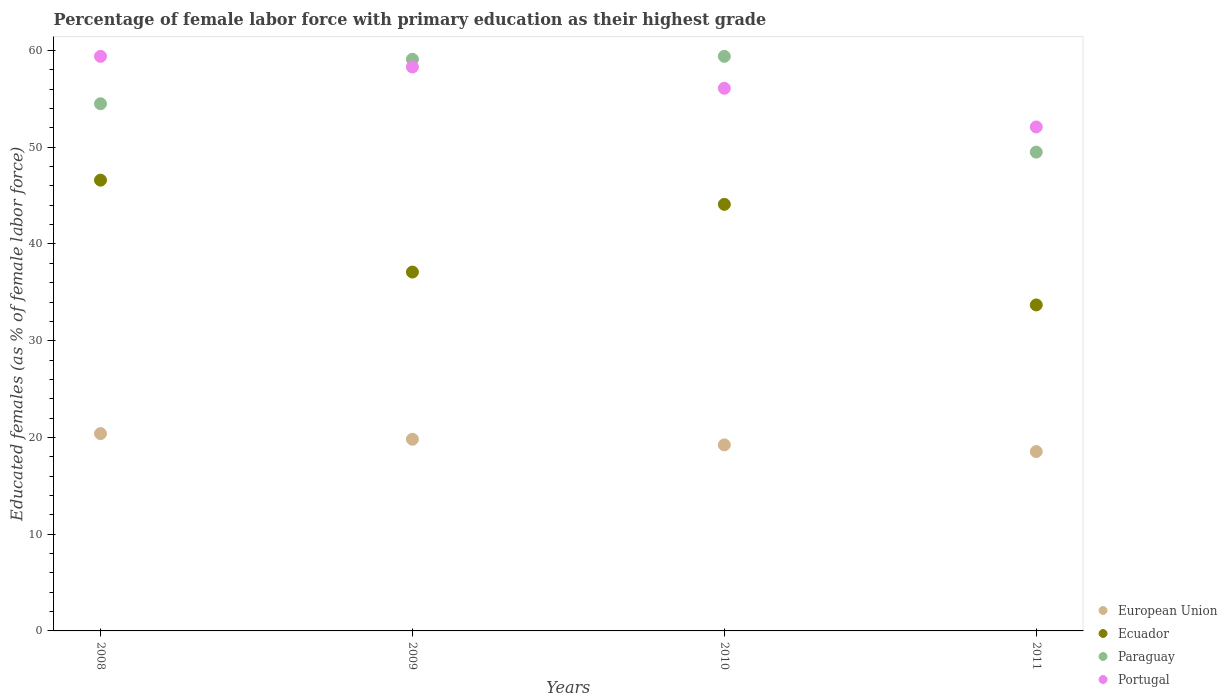What is the percentage of female labor force with primary education in Portugal in 2011?
Your response must be concise. 52.1. Across all years, what is the maximum percentage of female labor force with primary education in European Union?
Offer a terse response. 20.4. Across all years, what is the minimum percentage of female labor force with primary education in European Union?
Give a very brief answer. 18.54. In which year was the percentage of female labor force with primary education in Paraguay maximum?
Offer a terse response. 2010. What is the total percentage of female labor force with primary education in European Union in the graph?
Your answer should be compact. 77.99. What is the difference between the percentage of female labor force with primary education in Paraguay in 2010 and that in 2011?
Provide a short and direct response. 9.9. What is the average percentage of female labor force with primary education in Paraguay per year?
Offer a very short reply. 55.62. In the year 2009, what is the difference between the percentage of female labor force with primary education in Paraguay and percentage of female labor force with primary education in Portugal?
Provide a succinct answer. 0.8. What is the ratio of the percentage of female labor force with primary education in Paraguay in 2008 to that in 2011?
Make the answer very short. 1.1. Is the percentage of female labor force with primary education in Ecuador in 2009 less than that in 2011?
Offer a very short reply. No. What is the difference between the highest and the lowest percentage of female labor force with primary education in European Union?
Offer a terse response. 1.86. Is it the case that in every year, the sum of the percentage of female labor force with primary education in Portugal and percentage of female labor force with primary education in Ecuador  is greater than the sum of percentage of female labor force with primary education in Paraguay and percentage of female labor force with primary education in European Union?
Ensure brevity in your answer.  No. Does the percentage of female labor force with primary education in European Union monotonically increase over the years?
Provide a short and direct response. No. Is the percentage of female labor force with primary education in Ecuador strictly greater than the percentage of female labor force with primary education in Paraguay over the years?
Provide a succinct answer. No. Is the percentage of female labor force with primary education in Portugal strictly less than the percentage of female labor force with primary education in Paraguay over the years?
Ensure brevity in your answer.  No. How many years are there in the graph?
Offer a very short reply. 4. What is the difference between two consecutive major ticks on the Y-axis?
Your answer should be compact. 10. Are the values on the major ticks of Y-axis written in scientific E-notation?
Provide a succinct answer. No. Where does the legend appear in the graph?
Offer a very short reply. Bottom right. What is the title of the graph?
Provide a succinct answer. Percentage of female labor force with primary education as their highest grade. Does "Japan" appear as one of the legend labels in the graph?
Offer a terse response. No. What is the label or title of the X-axis?
Ensure brevity in your answer.  Years. What is the label or title of the Y-axis?
Give a very brief answer. Educated females (as % of female labor force). What is the Educated females (as % of female labor force) of European Union in 2008?
Ensure brevity in your answer.  20.4. What is the Educated females (as % of female labor force) in Ecuador in 2008?
Give a very brief answer. 46.6. What is the Educated females (as % of female labor force) of Paraguay in 2008?
Provide a short and direct response. 54.5. What is the Educated females (as % of female labor force) of Portugal in 2008?
Offer a very short reply. 59.4. What is the Educated females (as % of female labor force) in European Union in 2009?
Your answer should be very brief. 19.82. What is the Educated females (as % of female labor force) of Ecuador in 2009?
Your response must be concise. 37.1. What is the Educated females (as % of female labor force) of Paraguay in 2009?
Your response must be concise. 59.1. What is the Educated females (as % of female labor force) of Portugal in 2009?
Your answer should be very brief. 58.3. What is the Educated females (as % of female labor force) in European Union in 2010?
Keep it short and to the point. 19.23. What is the Educated females (as % of female labor force) in Ecuador in 2010?
Your answer should be very brief. 44.1. What is the Educated females (as % of female labor force) in Paraguay in 2010?
Your answer should be very brief. 59.4. What is the Educated females (as % of female labor force) in Portugal in 2010?
Offer a terse response. 56.1. What is the Educated females (as % of female labor force) of European Union in 2011?
Your answer should be compact. 18.54. What is the Educated females (as % of female labor force) of Ecuador in 2011?
Provide a short and direct response. 33.7. What is the Educated females (as % of female labor force) in Paraguay in 2011?
Ensure brevity in your answer.  49.5. What is the Educated females (as % of female labor force) in Portugal in 2011?
Your answer should be compact. 52.1. Across all years, what is the maximum Educated females (as % of female labor force) of European Union?
Offer a terse response. 20.4. Across all years, what is the maximum Educated females (as % of female labor force) of Ecuador?
Offer a terse response. 46.6. Across all years, what is the maximum Educated females (as % of female labor force) in Paraguay?
Your answer should be compact. 59.4. Across all years, what is the maximum Educated females (as % of female labor force) of Portugal?
Your answer should be very brief. 59.4. Across all years, what is the minimum Educated females (as % of female labor force) of European Union?
Offer a terse response. 18.54. Across all years, what is the minimum Educated females (as % of female labor force) in Ecuador?
Offer a very short reply. 33.7. Across all years, what is the minimum Educated females (as % of female labor force) of Paraguay?
Your answer should be compact. 49.5. Across all years, what is the minimum Educated females (as % of female labor force) of Portugal?
Your answer should be very brief. 52.1. What is the total Educated females (as % of female labor force) of European Union in the graph?
Offer a terse response. 77.99. What is the total Educated females (as % of female labor force) of Ecuador in the graph?
Your answer should be compact. 161.5. What is the total Educated females (as % of female labor force) of Paraguay in the graph?
Your response must be concise. 222.5. What is the total Educated females (as % of female labor force) in Portugal in the graph?
Provide a short and direct response. 225.9. What is the difference between the Educated females (as % of female labor force) in European Union in 2008 and that in 2009?
Your response must be concise. 0.58. What is the difference between the Educated females (as % of female labor force) of Paraguay in 2008 and that in 2009?
Your response must be concise. -4.6. What is the difference between the Educated females (as % of female labor force) in European Union in 2008 and that in 2010?
Your answer should be very brief. 1.17. What is the difference between the Educated females (as % of female labor force) in Ecuador in 2008 and that in 2010?
Make the answer very short. 2.5. What is the difference between the Educated females (as % of female labor force) in Paraguay in 2008 and that in 2010?
Provide a short and direct response. -4.9. What is the difference between the Educated females (as % of female labor force) of Portugal in 2008 and that in 2010?
Give a very brief answer. 3.3. What is the difference between the Educated females (as % of female labor force) of European Union in 2008 and that in 2011?
Give a very brief answer. 1.86. What is the difference between the Educated females (as % of female labor force) in Portugal in 2008 and that in 2011?
Your answer should be compact. 7.3. What is the difference between the Educated females (as % of female labor force) of European Union in 2009 and that in 2010?
Your answer should be compact. 0.58. What is the difference between the Educated females (as % of female labor force) in European Union in 2009 and that in 2011?
Keep it short and to the point. 1.27. What is the difference between the Educated females (as % of female labor force) in Portugal in 2009 and that in 2011?
Offer a very short reply. 6.2. What is the difference between the Educated females (as % of female labor force) in European Union in 2010 and that in 2011?
Offer a very short reply. 0.69. What is the difference between the Educated females (as % of female labor force) of Paraguay in 2010 and that in 2011?
Ensure brevity in your answer.  9.9. What is the difference between the Educated females (as % of female labor force) in Portugal in 2010 and that in 2011?
Make the answer very short. 4. What is the difference between the Educated females (as % of female labor force) in European Union in 2008 and the Educated females (as % of female labor force) in Ecuador in 2009?
Provide a short and direct response. -16.7. What is the difference between the Educated females (as % of female labor force) of European Union in 2008 and the Educated females (as % of female labor force) of Paraguay in 2009?
Ensure brevity in your answer.  -38.7. What is the difference between the Educated females (as % of female labor force) of European Union in 2008 and the Educated females (as % of female labor force) of Portugal in 2009?
Keep it short and to the point. -37.9. What is the difference between the Educated females (as % of female labor force) in Ecuador in 2008 and the Educated females (as % of female labor force) in Paraguay in 2009?
Provide a short and direct response. -12.5. What is the difference between the Educated females (as % of female labor force) in Ecuador in 2008 and the Educated females (as % of female labor force) in Portugal in 2009?
Your response must be concise. -11.7. What is the difference between the Educated females (as % of female labor force) in European Union in 2008 and the Educated females (as % of female labor force) in Ecuador in 2010?
Keep it short and to the point. -23.7. What is the difference between the Educated females (as % of female labor force) of European Union in 2008 and the Educated females (as % of female labor force) of Paraguay in 2010?
Give a very brief answer. -39. What is the difference between the Educated females (as % of female labor force) in European Union in 2008 and the Educated females (as % of female labor force) in Portugal in 2010?
Your answer should be very brief. -35.7. What is the difference between the Educated females (as % of female labor force) of Paraguay in 2008 and the Educated females (as % of female labor force) of Portugal in 2010?
Your answer should be very brief. -1.6. What is the difference between the Educated females (as % of female labor force) of European Union in 2008 and the Educated females (as % of female labor force) of Ecuador in 2011?
Offer a terse response. -13.3. What is the difference between the Educated females (as % of female labor force) in European Union in 2008 and the Educated females (as % of female labor force) in Paraguay in 2011?
Offer a terse response. -29.1. What is the difference between the Educated females (as % of female labor force) of European Union in 2008 and the Educated females (as % of female labor force) of Portugal in 2011?
Give a very brief answer. -31.7. What is the difference between the Educated females (as % of female labor force) in Ecuador in 2008 and the Educated females (as % of female labor force) in Paraguay in 2011?
Your answer should be very brief. -2.9. What is the difference between the Educated females (as % of female labor force) in Ecuador in 2008 and the Educated females (as % of female labor force) in Portugal in 2011?
Provide a succinct answer. -5.5. What is the difference between the Educated females (as % of female labor force) in European Union in 2009 and the Educated females (as % of female labor force) in Ecuador in 2010?
Provide a short and direct response. -24.28. What is the difference between the Educated females (as % of female labor force) of European Union in 2009 and the Educated females (as % of female labor force) of Paraguay in 2010?
Your response must be concise. -39.58. What is the difference between the Educated females (as % of female labor force) in European Union in 2009 and the Educated females (as % of female labor force) in Portugal in 2010?
Ensure brevity in your answer.  -36.28. What is the difference between the Educated females (as % of female labor force) in Ecuador in 2009 and the Educated females (as % of female labor force) in Paraguay in 2010?
Offer a terse response. -22.3. What is the difference between the Educated females (as % of female labor force) of Ecuador in 2009 and the Educated females (as % of female labor force) of Portugal in 2010?
Provide a succinct answer. -19. What is the difference between the Educated females (as % of female labor force) of Paraguay in 2009 and the Educated females (as % of female labor force) of Portugal in 2010?
Keep it short and to the point. 3. What is the difference between the Educated females (as % of female labor force) in European Union in 2009 and the Educated females (as % of female labor force) in Ecuador in 2011?
Your answer should be compact. -13.88. What is the difference between the Educated females (as % of female labor force) in European Union in 2009 and the Educated females (as % of female labor force) in Paraguay in 2011?
Your answer should be very brief. -29.68. What is the difference between the Educated females (as % of female labor force) in European Union in 2009 and the Educated females (as % of female labor force) in Portugal in 2011?
Ensure brevity in your answer.  -32.28. What is the difference between the Educated females (as % of female labor force) in European Union in 2010 and the Educated females (as % of female labor force) in Ecuador in 2011?
Provide a succinct answer. -14.47. What is the difference between the Educated females (as % of female labor force) in European Union in 2010 and the Educated females (as % of female labor force) in Paraguay in 2011?
Keep it short and to the point. -30.27. What is the difference between the Educated females (as % of female labor force) of European Union in 2010 and the Educated females (as % of female labor force) of Portugal in 2011?
Provide a succinct answer. -32.87. What is the difference between the Educated females (as % of female labor force) in Ecuador in 2010 and the Educated females (as % of female labor force) in Portugal in 2011?
Your response must be concise. -8. What is the difference between the Educated females (as % of female labor force) of Paraguay in 2010 and the Educated females (as % of female labor force) of Portugal in 2011?
Your answer should be very brief. 7.3. What is the average Educated females (as % of female labor force) in European Union per year?
Your answer should be very brief. 19.5. What is the average Educated females (as % of female labor force) of Ecuador per year?
Your answer should be compact. 40.38. What is the average Educated females (as % of female labor force) in Paraguay per year?
Ensure brevity in your answer.  55.62. What is the average Educated females (as % of female labor force) in Portugal per year?
Make the answer very short. 56.48. In the year 2008, what is the difference between the Educated females (as % of female labor force) in European Union and Educated females (as % of female labor force) in Ecuador?
Provide a short and direct response. -26.2. In the year 2008, what is the difference between the Educated females (as % of female labor force) in European Union and Educated females (as % of female labor force) in Paraguay?
Provide a short and direct response. -34.1. In the year 2008, what is the difference between the Educated females (as % of female labor force) of European Union and Educated females (as % of female labor force) of Portugal?
Your response must be concise. -39. In the year 2008, what is the difference between the Educated females (as % of female labor force) of Ecuador and Educated females (as % of female labor force) of Paraguay?
Offer a very short reply. -7.9. In the year 2009, what is the difference between the Educated females (as % of female labor force) of European Union and Educated females (as % of female labor force) of Ecuador?
Give a very brief answer. -17.28. In the year 2009, what is the difference between the Educated females (as % of female labor force) of European Union and Educated females (as % of female labor force) of Paraguay?
Provide a succinct answer. -39.28. In the year 2009, what is the difference between the Educated females (as % of female labor force) of European Union and Educated females (as % of female labor force) of Portugal?
Offer a very short reply. -38.48. In the year 2009, what is the difference between the Educated females (as % of female labor force) of Ecuador and Educated females (as % of female labor force) of Paraguay?
Make the answer very short. -22. In the year 2009, what is the difference between the Educated females (as % of female labor force) in Ecuador and Educated females (as % of female labor force) in Portugal?
Your answer should be compact. -21.2. In the year 2009, what is the difference between the Educated females (as % of female labor force) in Paraguay and Educated females (as % of female labor force) in Portugal?
Provide a short and direct response. 0.8. In the year 2010, what is the difference between the Educated females (as % of female labor force) in European Union and Educated females (as % of female labor force) in Ecuador?
Your answer should be very brief. -24.87. In the year 2010, what is the difference between the Educated females (as % of female labor force) in European Union and Educated females (as % of female labor force) in Paraguay?
Provide a succinct answer. -40.17. In the year 2010, what is the difference between the Educated females (as % of female labor force) of European Union and Educated females (as % of female labor force) of Portugal?
Your answer should be very brief. -36.87. In the year 2010, what is the difference between the Educated females (as % of female labor force) of Ecuador and Educated females (as % of female labor force) of Paraguay?
Give a very brief answer. -15.3. In the year 2010, what is the difference between the Educated females (as % of female labor force) of Paraguay and Educated females (as % of female labor force) of Portugal?
Offer a terse response. 3.3. In the year 2011, what is the difference between the Educated females (as % of female labor force) of European Union and Educated females (as % of female labor force) of Ecuador?
Your answer should be very brief. -15.16. In the year 2011, what is the difference between the Educated females (as % of female labor force) of European Union and Educated females (as % of female labor force) of Paraguay?
Provide a succinct answer. -30.96. In the year 2011, what is the difference between the Educated females (as % of female labor force) in European Union and Educated females (as % of female labor force) in Portugal?
Give a very brief answer. -33.56. In the year 2011, what is the difference between the Educated females (as % of female labor force) in Ecuador and Educated females (as % of female labor force) in Paraguay?
Make the answer very short. -15.8. In the year 2011, what is the difference between the Educated females (as % of female labor force) of Ecuador and Educated females (as % of female labor force) of Portugal?
Make the answer very short. -18.4. What is the ratio of the Educated females (as % of female labor force) in European Union in 2008 to that in 2009?
Provide a succinct answer. 1.03. What is the ratio of the Educated females (as % of female labor force) of Ecuador in 2008 to that in 2009?
Offer a terse response. 1.26. What is the ratio of the Educated females (as % of female labor force) of Paraguay in 2008 to that in 2009?
Make the answer very short. 0.92. What is the ratio of the Educated females (as % of female labor force) in Portugal in 2008 to that in 2009?
Your answer should be compact. 1.02. What is the ratio of the Educated females (as % of female labor force) of European Union in 2008 to that in 2010?
Offer a terse response. 1.06. What is the ratio of the Educated females (as % of female labor force) of Ecuador in 2008 to that in 2010?
Offer a terse response. 1.06. What is the ratio of the Educated females (as % of female labor force) in Paraguay in 2008 to that in 2010?
Provide a short and direct response. 0.92. What is the ratio of the Educated females (as % of female labor force) of Portugal in 2008 to that in 2010?
Ensure brevity in your answer.  1.06. What is the ratio of the Educated females (as % of female labor force) of European Union in 2008 to that in 2011?
Give a very brief answer. 1.1. What is the ratio of the Educated females (as % of female labor force) of Ecuador in 2008 to that in 2011?
Give a very brief answer. 1.38. What is the ratio of the Educated females (as % of female labor force) in Paraguay in 2008 to that in 2011?
Your answer should be very brief. 1.1. What is the ratio of the Educated females (as % of female labor force) in Portugal in 2008 to that in 2011?
Ensure brevity in your answer.  1.14. What is the ratio of the Educated females (as % of female labor force) in European Union in 2009 to that in 2010?
Offer a terse response. 1.03. What is the ratio of the Educated females (as % of female labor force) in Ecuador in 2009 to that in 2010?
Give a very brief answer. 0.84. What is the ratio of the Educated females (as % of female labor force) of Portugal in 2009 to that in 2010?
Offer a very short reply. 1.04. What is the ratio of the Educated females (as % of female labor force) in European Union in 2009 to that in 2011?
Ensure brevity in your answer.  1.07. What is the ratio of the Educated females (as % of female labor force) in Ecuador in 2009 to that in 2011?
Give a very brief answer. 1.1. What is the ratio of the Educated females (as % of female labor force) of Paraguay in 2009 to that in 2011?
Keep it short and to the point. 1.19. What is the ratio of the Educated females (as % of female labor force) in Portugal in 2009 to that in 2011?
Provide a short and direct response. 1.12. What is the ratio of the Educated females (as % of female labor force) of European Union in 2010 to that in 2011?
Ensure brevity in your answer.  1.04. What is the ratio of the Educated females (as % of female labor force) of Ecuador in 2010 to that in 2011?
Your answer should be compact. 1.31. What is the ratio of the Educated females (as % of female labor force) in Paraguay in 2010 to that in 2011?
Your response must be concise. 1.2. What is the ratio of the Educated females (as % of female labor force) of Portugal in 2010 to that in 2011?
Your response must be concise. 1.08. What is the difference between the highest and the second highest Educated females (as % of female labor force) of European Union?
Your answer should be very brief. 0.58. What is the difference between the highest and the second highest Educated females (as % of female labor force) of Ecuador?
Provide a succinct answer. 2.5. What is the difference between the highest and the second highest Educated females (as % of female labor force) in Portugal?
Keep it short and to the point. 1.1. What is the difference between the highest and the lowest Educated females (as % of female labor force) of European Union?
Offer a very short reply. 1.86. What is the difference between the highest and the lowest Educated females (as % of female labor force) in Portugal?
Offer a terse response. 7.3. 